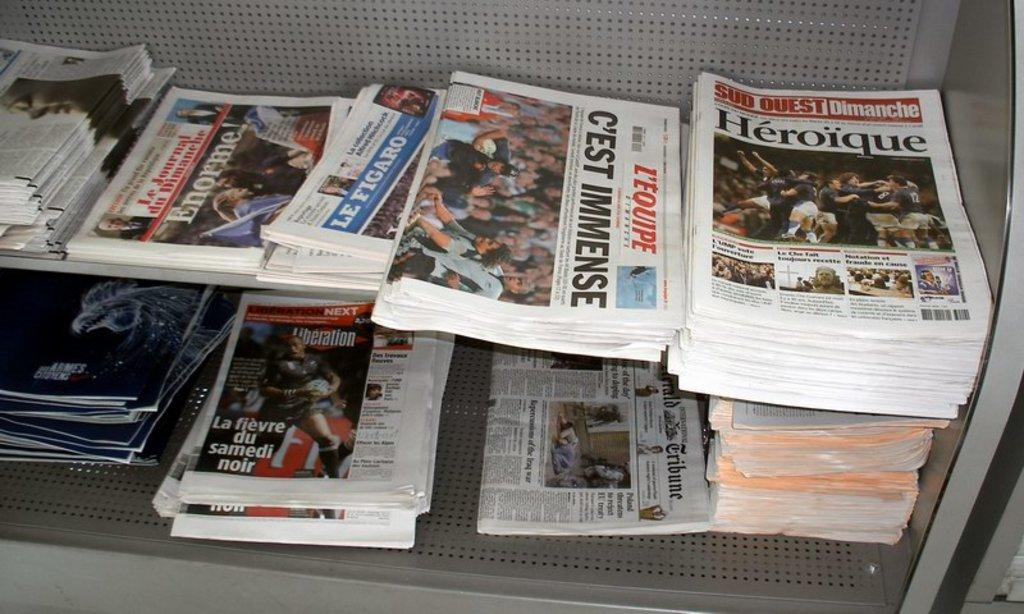Provide a one-sentence caption for the provided image. Several newspapers on a shelf discuss the headline "Heroique.". 